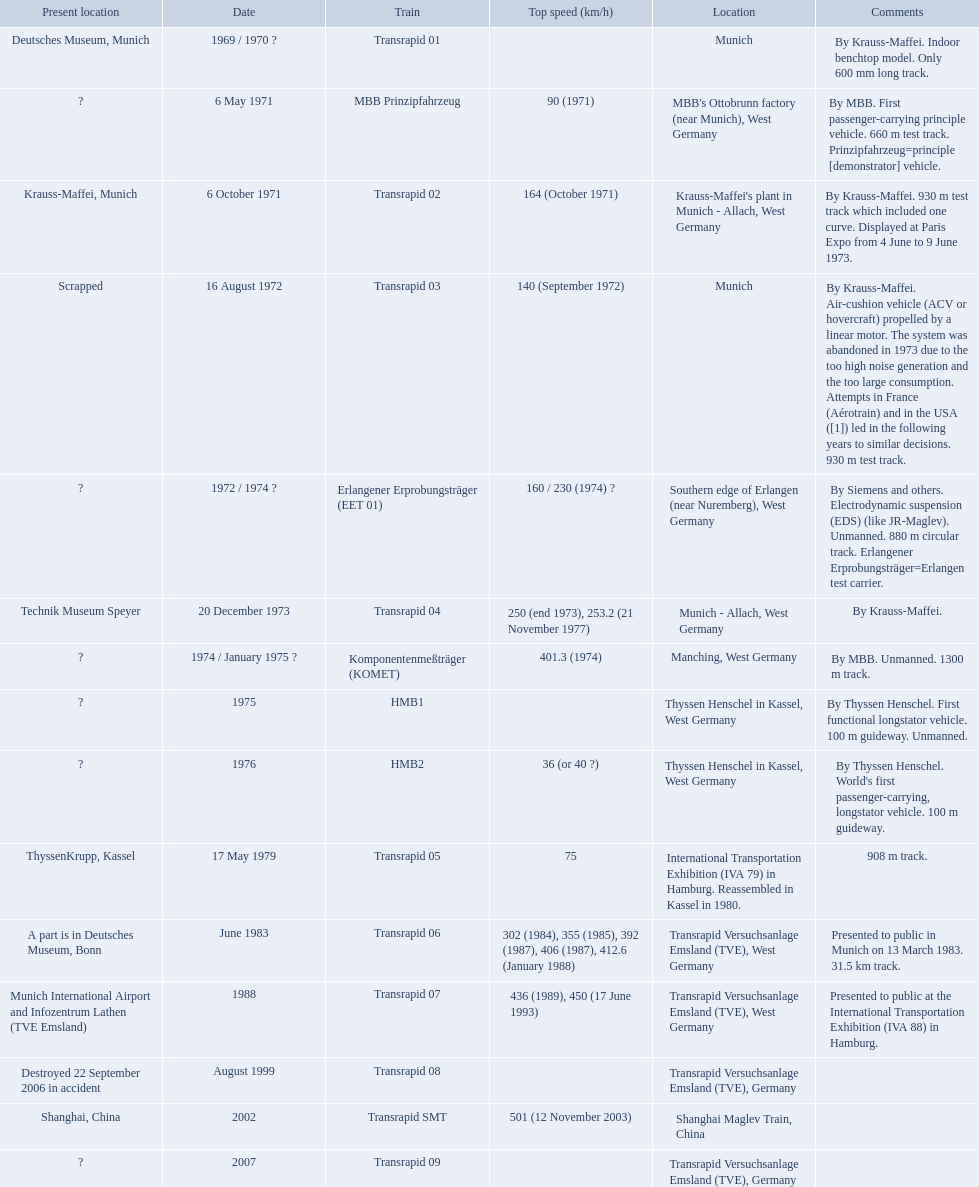What are all of the transrapid trains? Transrapid 01, Transrapid 02, Transrapid 03, Transrapid 04, Transrapid 05, Transrapid 06, Transrapid 07, Transrapid 08, Transrapid SMT, Transrapid 09. Of those, which train had to be scrapped? Transrapid 03. Which trains exceeded a top speed of 400+? Komponentenmeßträger (KOMET), Transrapid 07, Transrapid SMT. How about 500+? Transrapid SMT. 